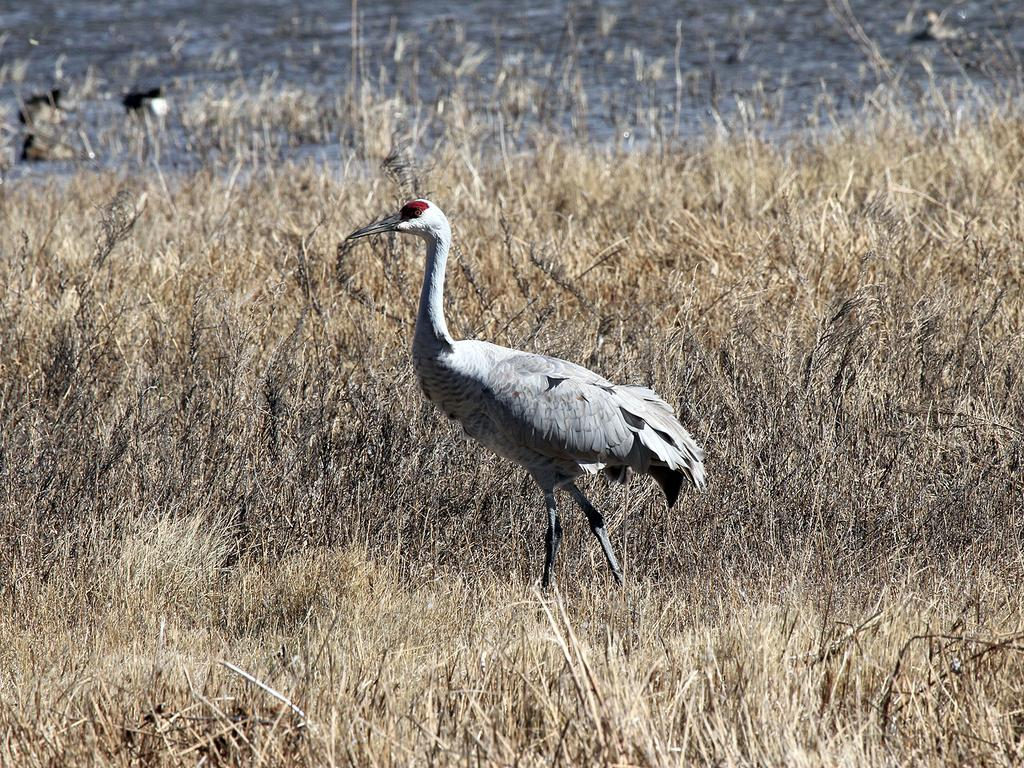What type of vegetation is present in the image? There is grass in the image. What type of animal can be seen in the image? There is a bird in the image. What can be seen in the background of the image? There is water visible in the background of the image. What type of wool is the bird using to transport the grass in the image? There is no wool or transportation of grass depicted in the image; the bird is simply present in the grassy area. 